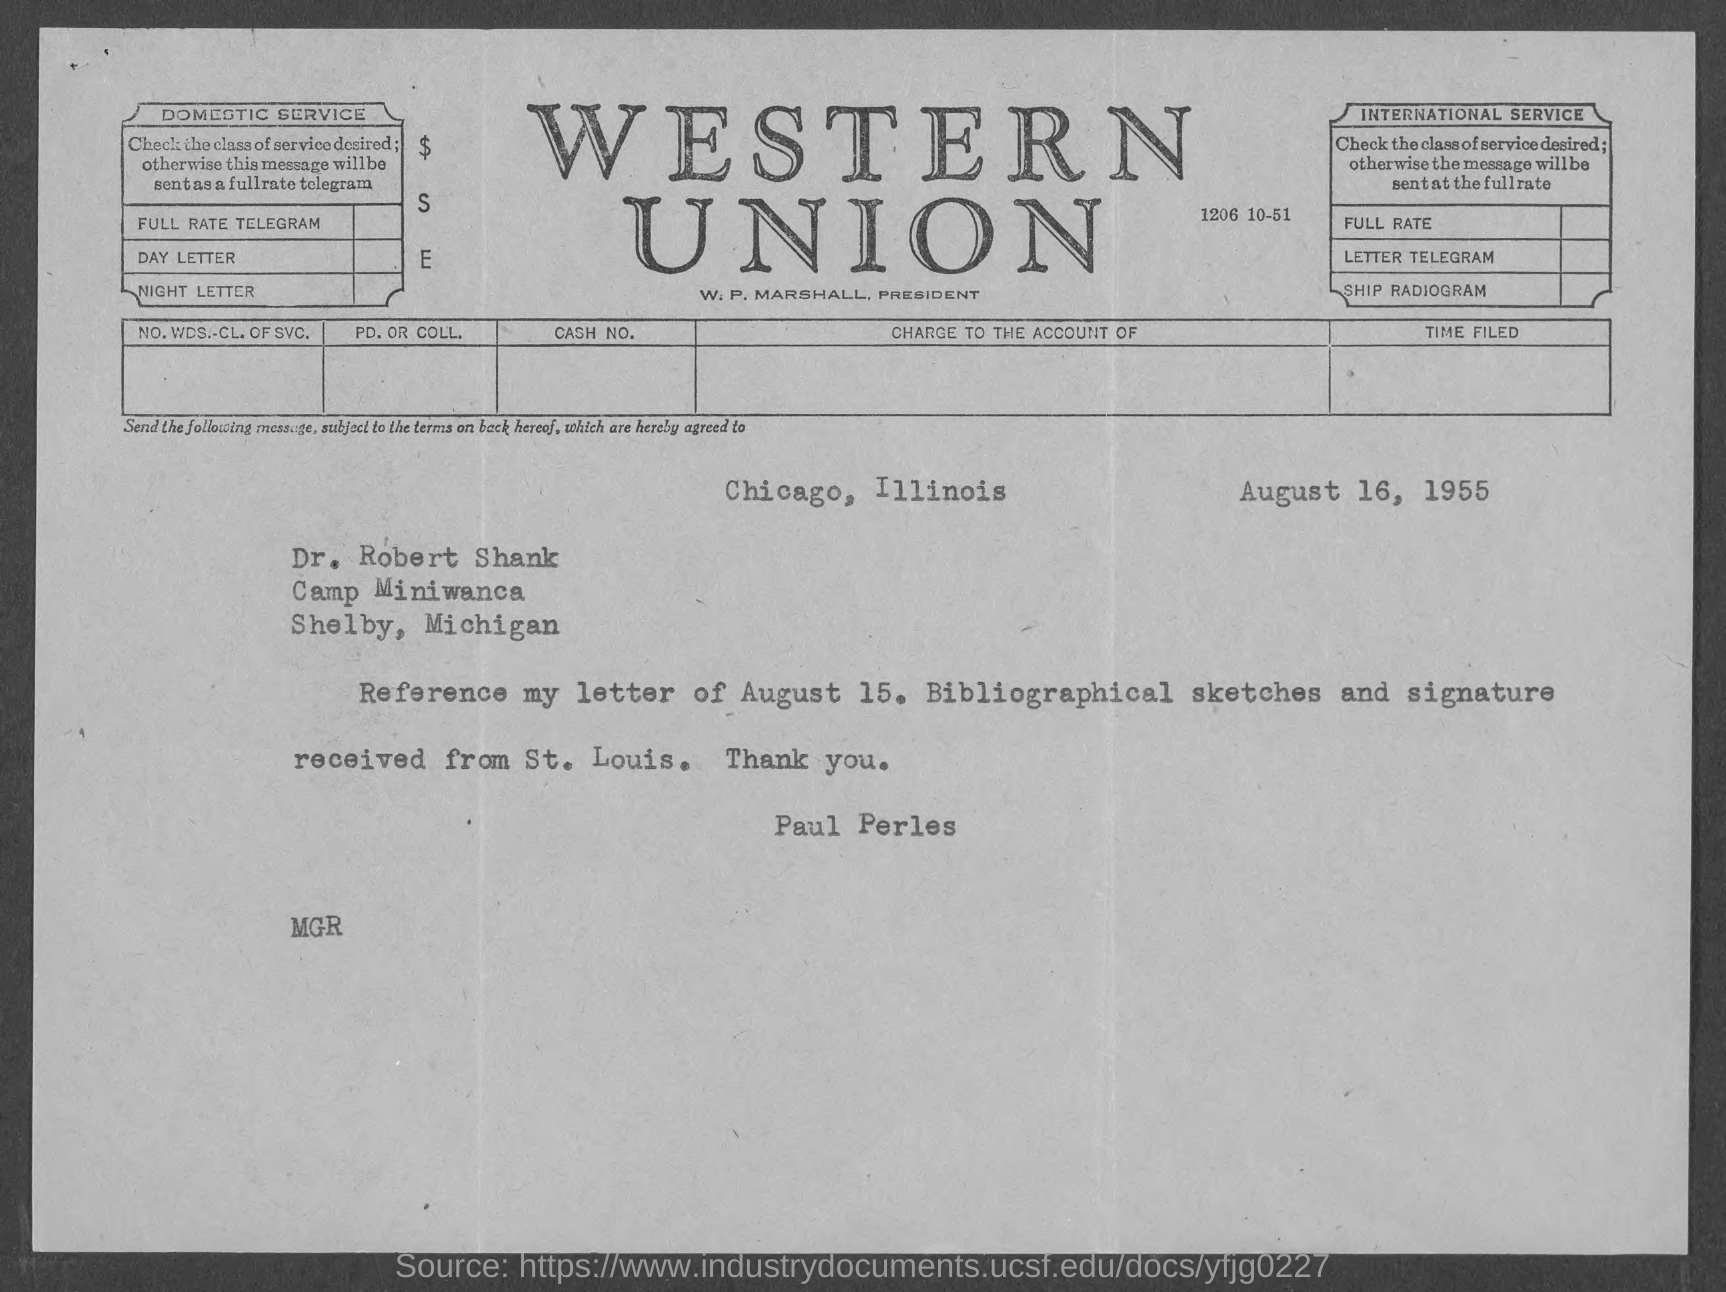Draw attention to some important aspects in this diagram. The document is dated August 16, 1955. The document is sent from Chicago, Illinois. The sender is Paul Perles. 